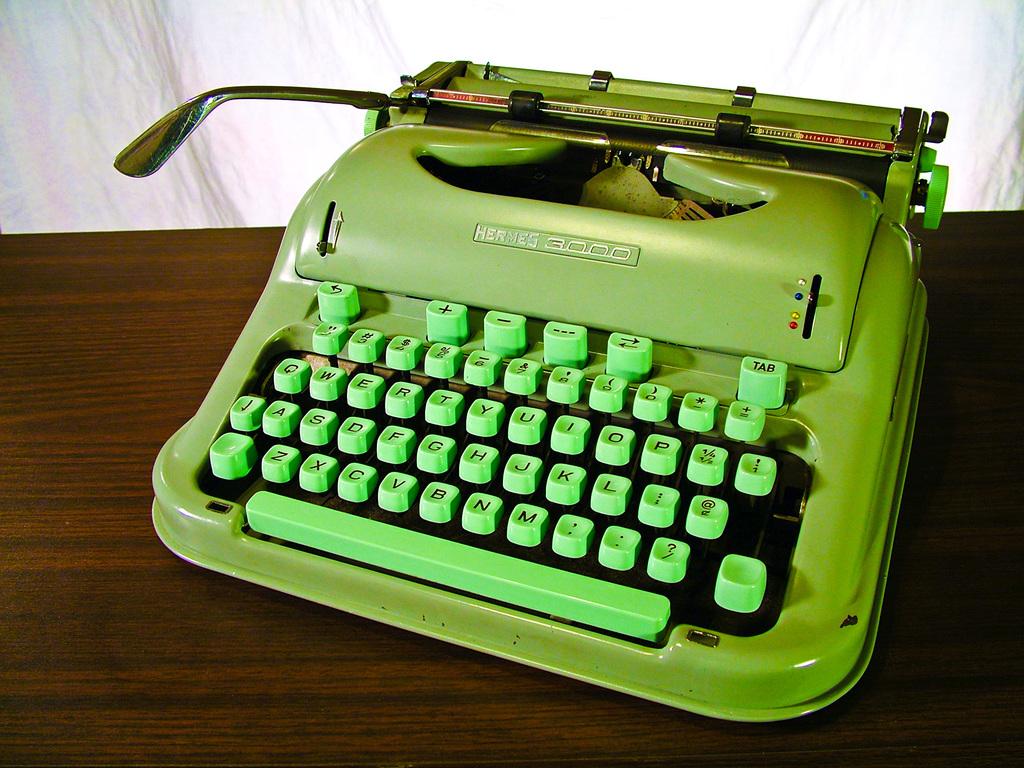What is this brand of typewriter?
Provide a succinct answer. Hermes. What is the top right key?
Give a very brief answer. Tab. 